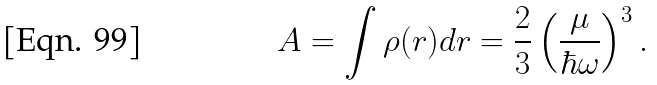Convert formula to latex. <formula><loc_0><loc_0><loc_500><loc_500>A = \int \rho ( r ) d { r } = \frac { 2 } { 3 } \left ( \frac { \mu } { \hbar { \omega } } \right ) ^ { 3 } .</formula> 